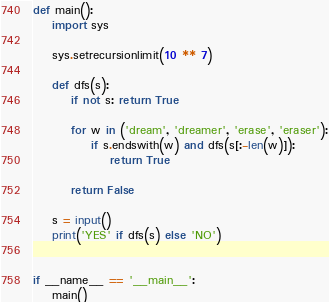<code> <loc_0><loc_0><loc_500><loc_500><_Python_>def main():
    import sys

    sys.setrecursionlimit(10 ** 7)

    def dfs(s):
        if not s: return True

        for w in ('dream', 'dreamer', 'erase', 'eraser'):
            if s.endswith(w) and dfs(s[:-len(w)]):
                return True

        return False

    s = input()
    print('YES' if dfs(s) else 'NO')


if __name__ == '__main__':
    main()
</code> 